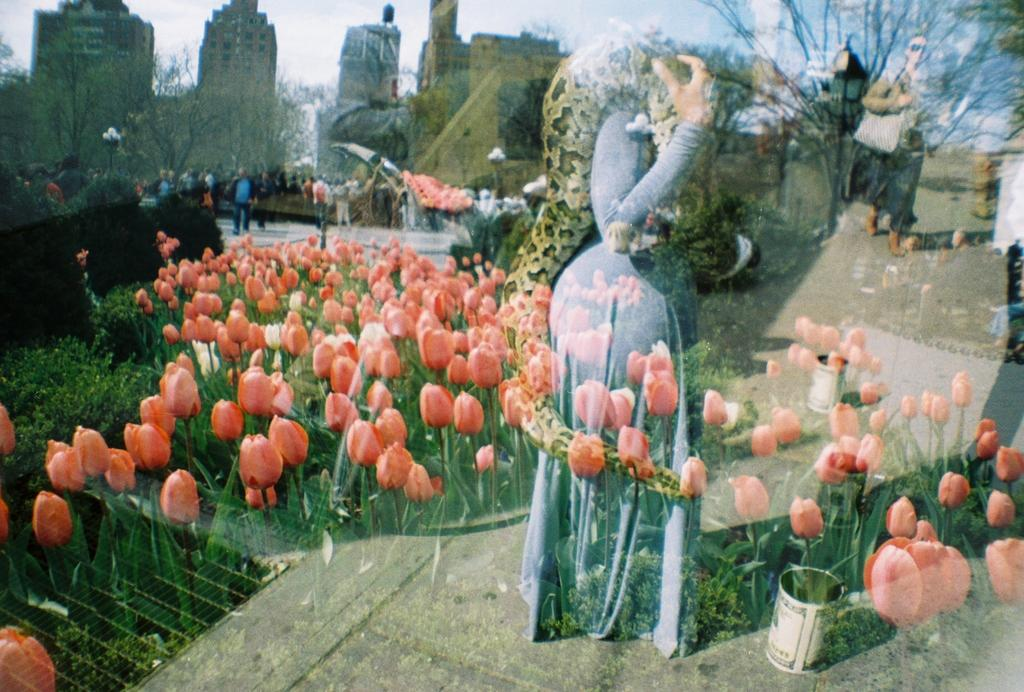What are the women in the image doing? The women are standing on the road in the image. What type of structures can be seen in the image? There are buildings in the image. What type of vegetation is present in the image? There are trees, plants, and flowers in the image. What type of urban infrastructure is visible in the image? There are street poles, street lights, and bins in the image. What part of the natural environment is visible in the image? The sky is visible in the image. What type of health advice can be seen on the bins in the image? There is no health advice present on the bins in the image. What type of sister can be seen interacting with the women in the image? There is no sister present in the image. 